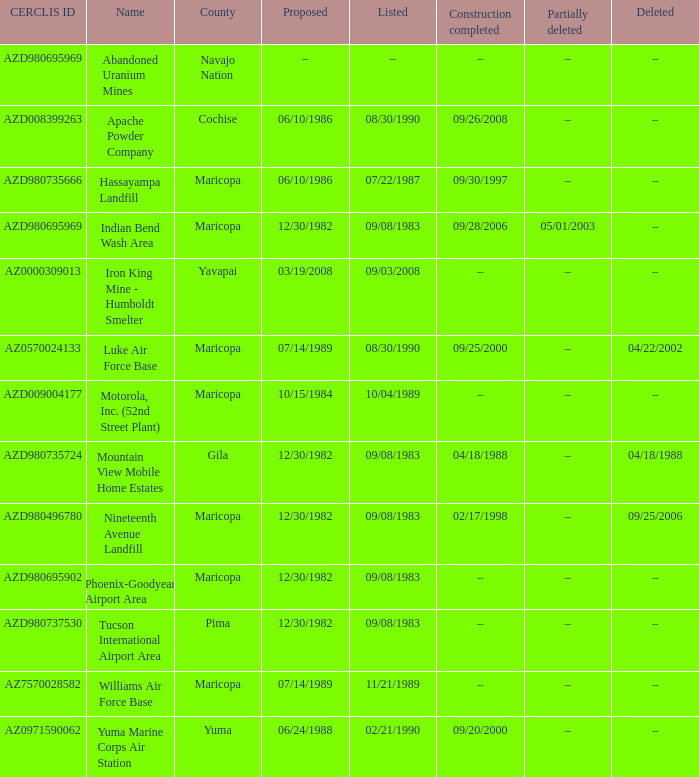When was the site listed when the county is cochise? 08/30/1990. 